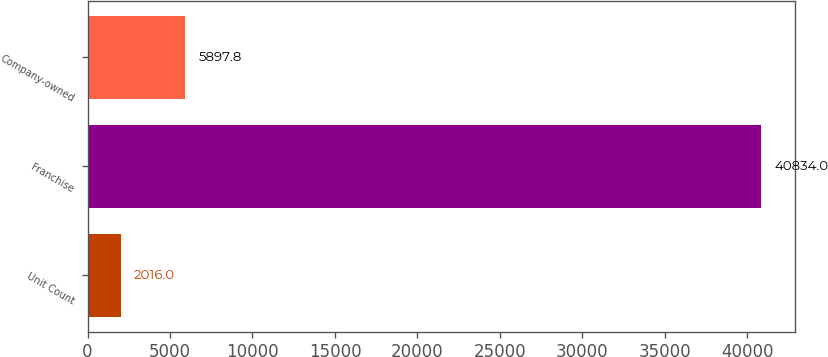<chart> <loc_0><loc_0><loc_500><loc_500><bar_chart><fcel>Unit Count<fcel>Franchise<fcel>Company-owned<nl><fcel>2016<fcel>40834<fcel>5897.8<nl></chart> 